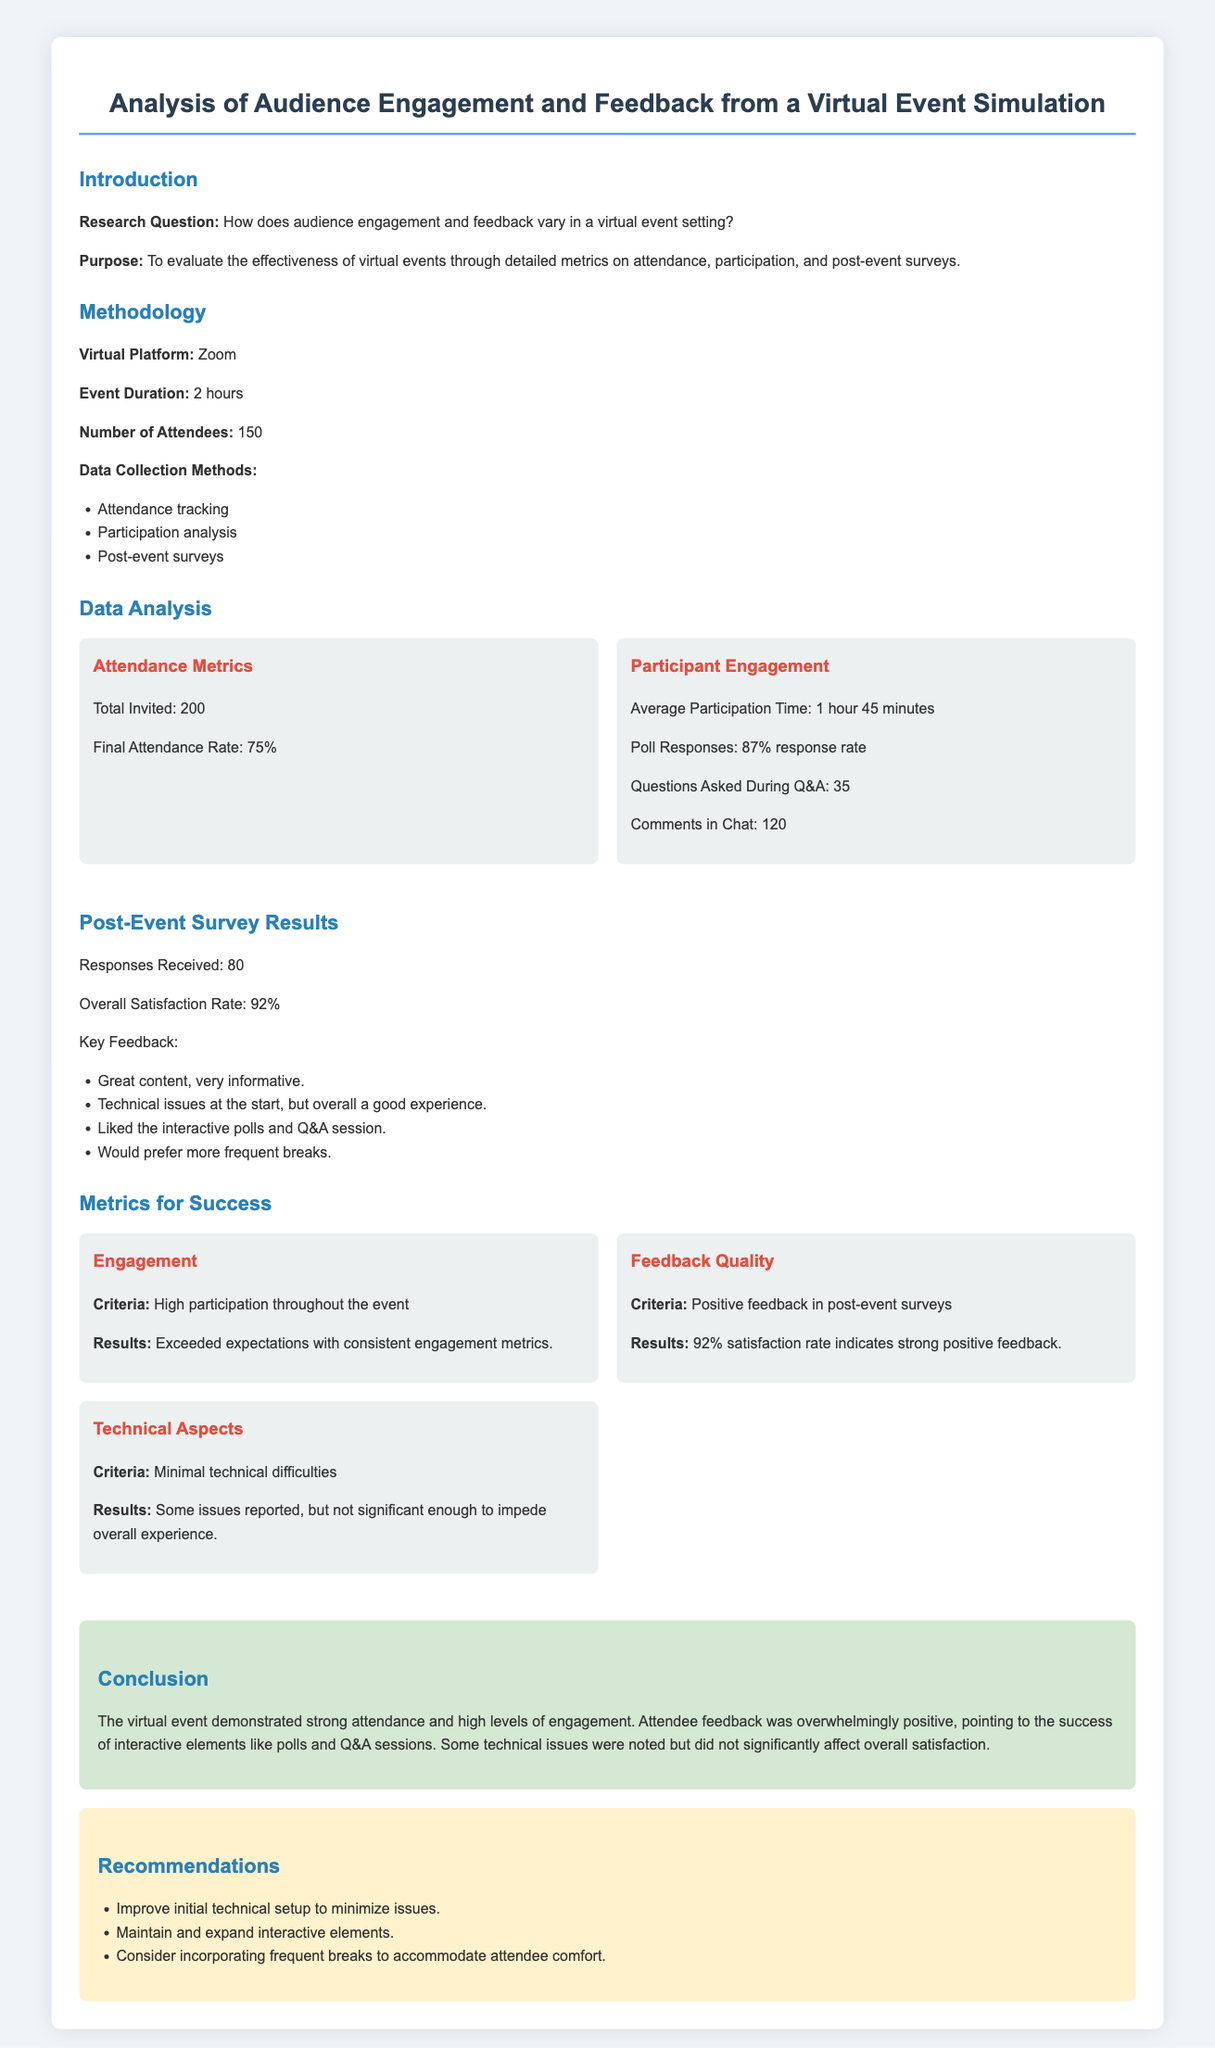What is the total number of attendees? The document states that there were 150 attendees in the virtual event.
Answer: 150 What was the final attendance rate? The final attendance rate is mentioned as 75% of the total invited.
Answer: 75% What is the overall satisfaction rate from the post-event survey? The overall satisfaction rate is provided in the survey results as 92%.
Answer: 92% What feedback did attendees provide regarding technical issues? The key feedback includes mention of technical issues at the start of the event.
Answer: Technical issues at the start What is one recommendation for future events? The document suggests improving initial technical setup as one of the recommendations.
Answer: Improve initial technical setup How many responses were received for the post-event survey? The document states that 80 responses were received for the post-event survey.
Answer: 80 What platform was used for the virtual event? The virtual platform utilized for the event is specified in the document as Zoom.
Answer: Zoom What was the average participation time during the event? The average participation time is mentioned as 1 hour 45 minutes in the participation analysis.
Answer: 1 hour 45 minutes What is the success criterion for technical aspects? The document states that the criterion for technical aspects includes minimal technical difficulties.
Answer: Minimal technical difficulties 